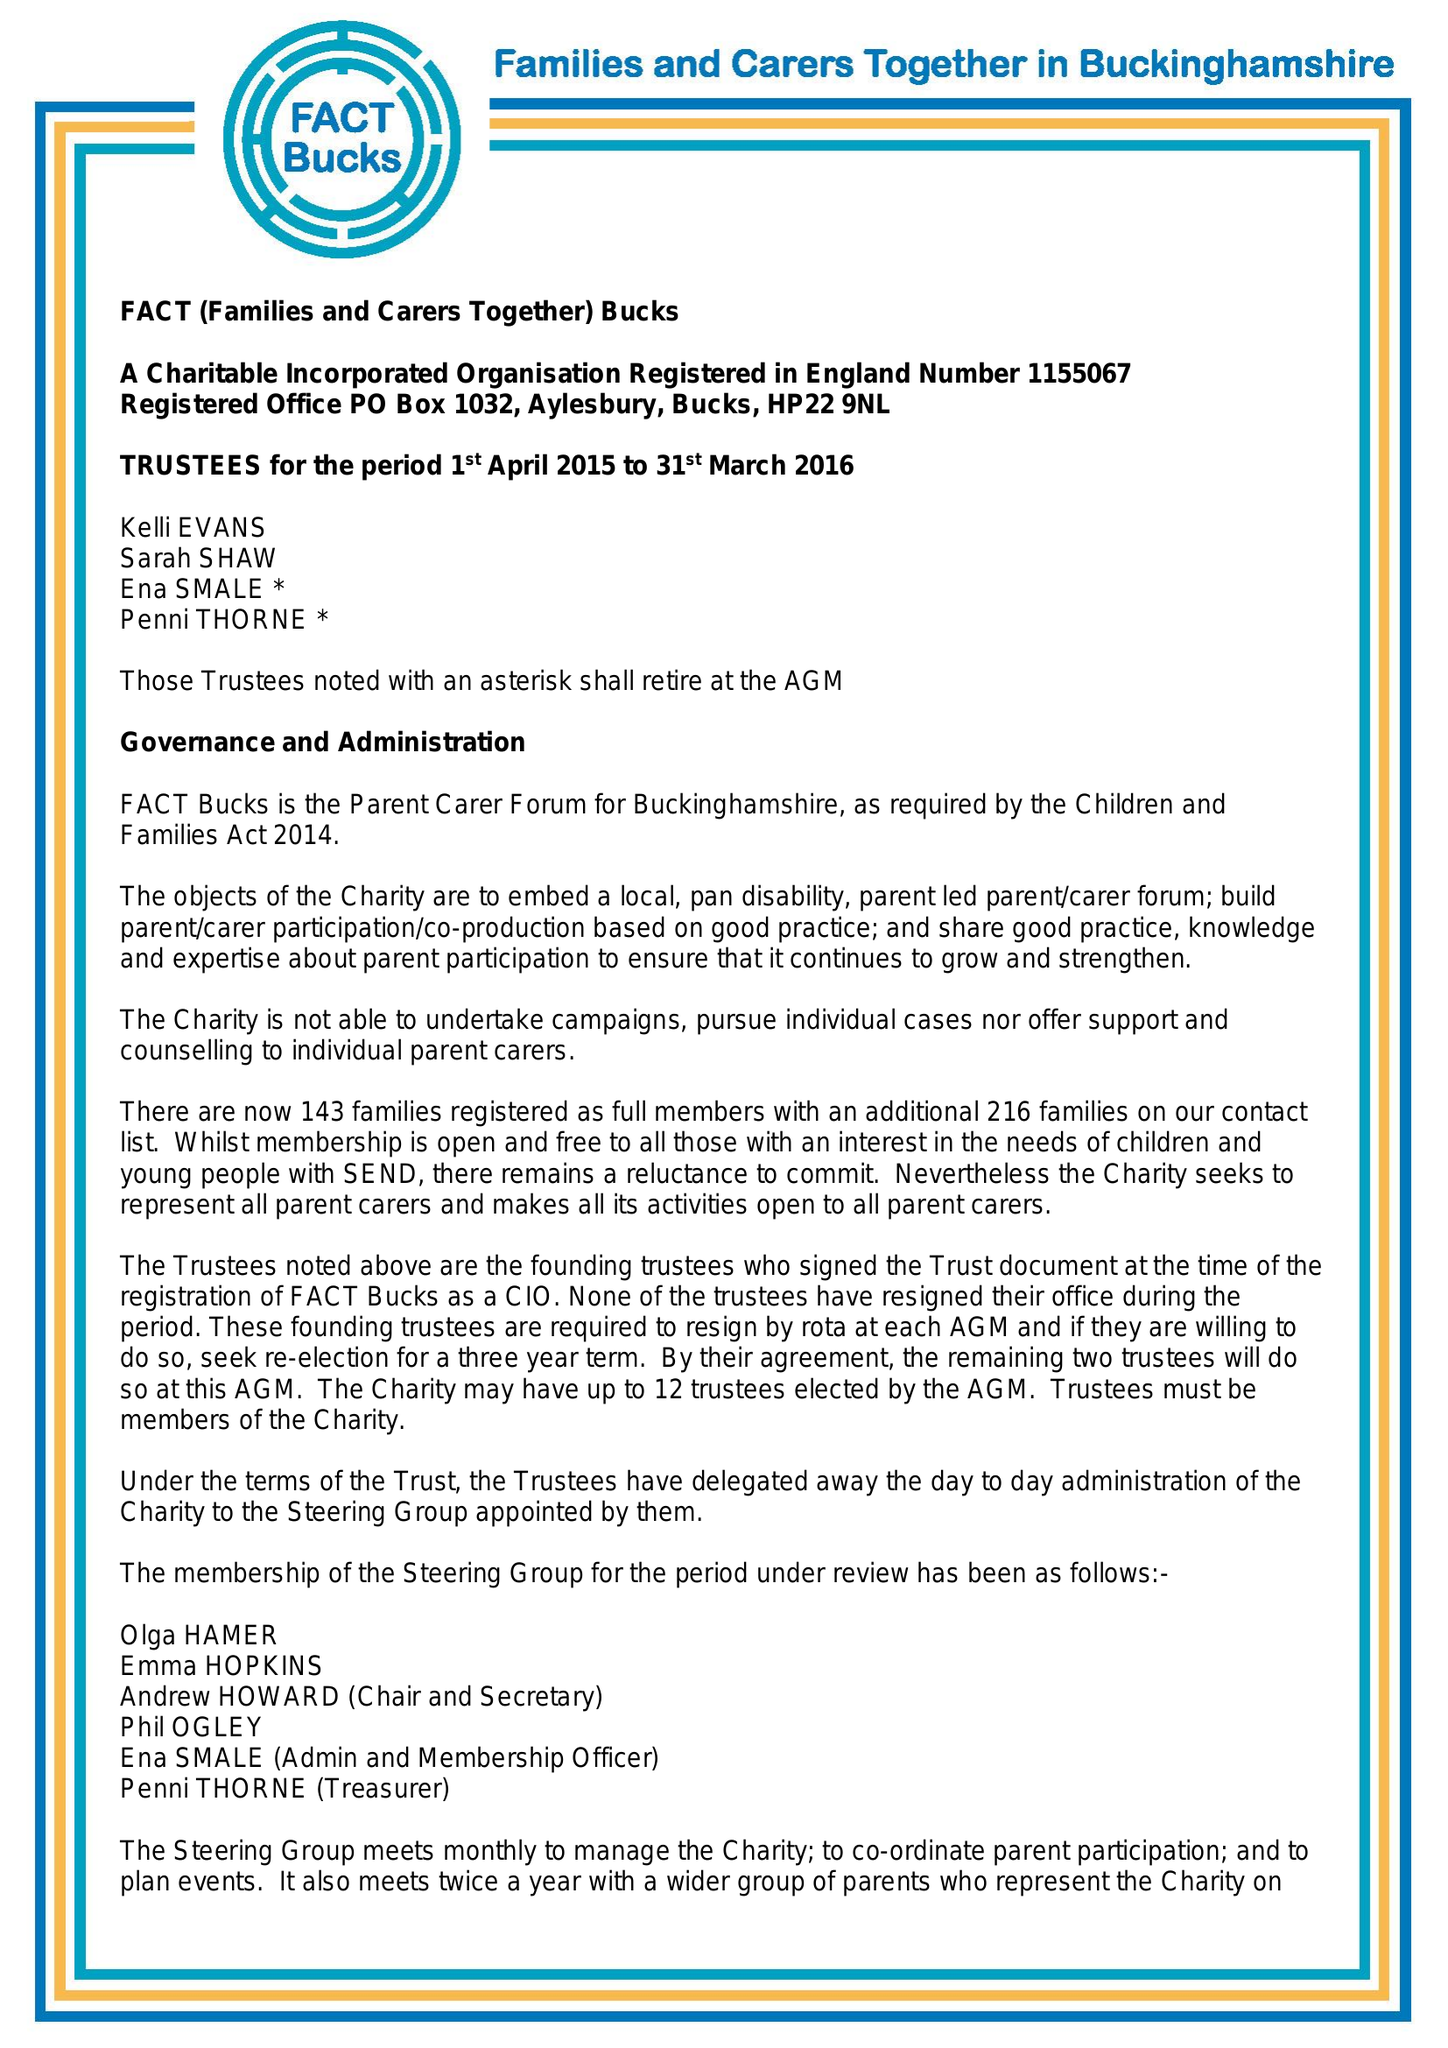What is the value for the address__post_town?
Answer the question using a single word or phrase. PRINCES RISBOROUGH 